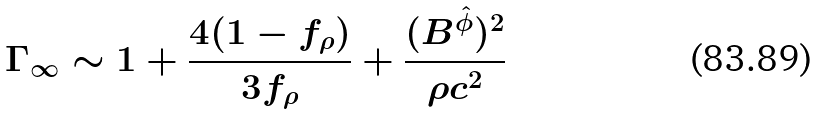<formula> <loc_0><loc_0><loc_500><loc_500>\Gamma _ { \infty } \sim 1 + \frac { 4 ( 1 - f _ { \rho } ) } { 3 f _ { \rho } } + \frac { ( B ^ { \hat { \phi } } ) ^ { 2 } } { \rho c ^ { 2 } }</formula> 